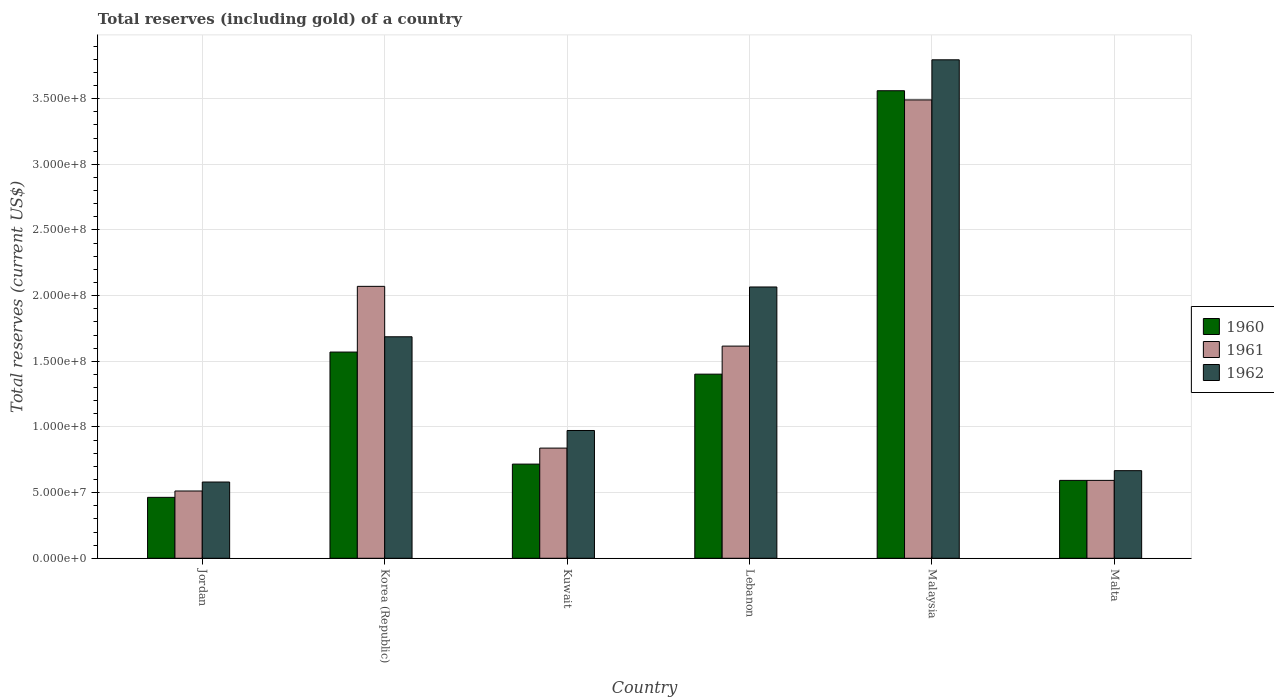How many different coloured bars are there?
Ensure brevity in your answer.  3. How many groups of bars are there?
Make the answer very short. 6. How many bars are there on the 2nd tick from the right?
Your response must be concise. 3. What is the label of the 3rd group of bars from the left?
Your response must be concise. Kuwait. In how many cases, is the number of bars for a given country not equal to the number of legend labels?
Provide a succinct answer. 0. What is the total reserves (including gold) in 1962 in Malaysia?
Keep it short and to the point. 3.80e+08. Across all countries, what is the maximum total reserves (including gold) in 1962?
Your response must be concise. 3.80e+08. Across all countries, what is the minimum total reserves (including gold) in 1961?
Offer a terse response. 5.12e+07. In which country was the total reserves (including gold) in 1961 maximum?
Ensure brevity in your answer.  Malaysia. In which country was the total reserves (including gold) in 1961 minimum?
Your answer should be very brief. Jordan. What is the total total reserves (including gold) in 1960 in the graph?
Offer a very short reply. 8.31e+08. What is the difference between the total reserves (including gold) in 1961 in Malaysia and that in Malta?
Your response must be concise. 2.90e+08. What is the difference between the total reserves (including gold) in 1961 in Lebanon and the total reserves (including gold) in 1962 in Korea (Republic)?
Make the answer very short. -7.10e+06. What is the average total reserves (including gold) in 1960 per country?
Give a very brief answer. 1.38e+08. What is the difference between the total reserves (including gold) of/in 1960 and total reserves (including gold) of/in 1961 in Kuwait?
Keep it short and to the point. -1.22e+07. In how many countries, is the total reserves (including gold) in 1962 greater than 180000000 US$?
Give a very brief answer. 2. What is the ratio of the total reserves (including gold) in 1960 in Jordan to that in Kuwait?
Your answer should be compact. 0.65. Is the difference between the total reserves (including gold) in 1960 in Malaysia and Malta greater than the difference between the total reserves (including gold) in 1961 in Malaysia and Malta?
Make the answer very short. Yes. What is the difference between the highest and the second highest total reserves (including gold) in 1961?
Offer a terse response. 1.87e+08. What is the difference between the highest and the lowest total reserves (including gold) in 1960?
Offer a terse response. 3.10e+08. What does the 2nd bar from the left in Lebanon represents?
Keep it short and to the point. 1961. How many bars are there?
Provide a succinct answer. 18. Are all the bars in the graph horizontal?
Offer a terse response. No. Are the values on the major ticks of Y-axis written in scientific E-notation?
Ensure brevity in your answer.  Yes. Does the graph contain any zero values?
Give a very brief answer. No. Does the graph contain grids?
Your response must be concise. Yes. How many legend labels are there?
Offer a terse response. 3. How are the legend labels stacked?
Your answer should be compact. Vertical. What is the title of the graph?
Make the answer very short. Total reserves (including gold) of a country. What is the label or title of the Y-axis?
Make the answer very short. Total reserves (current US$). What is the Total reserves (current US$) of 1960 in Jordan?
Offer a terse response. 4.64e+07. What is the Total reserves (current US$) of 1961 in Jordan?
Provide a short and direct response. 5.12e+07. What is the Total reserves (current US$) of 1962 in Jordan?
Your answer should be compact. 5.80e+07. What is the Total reserves (current US$) in 1960 in Korea (Republic)?
Give a very brief answer. 1.57e+08. What is the Total reserves (current US$) in 1961 in Korea (Republic)?
Offer a terse response. 2.07e+08. What is the Total reserves (current US$) of 1962 in Korea (Republic)?
Ensure brevity in your answer.  1.69e+08. What is the Total reserves (current US$) in 1960 in Kuwait?
Provide a succinct answer. 7.17e+07. What is the Total reserves (current US$) of 1961 in Kuwait?
Your response must be concise. 8.39e+07. What is the Total reserves (current US$) in 1962 in Kuwait?
Your answer should be compact. 9.73e+07. What is the Total reserves (current US$) in 1960 in Lebanon?
Your answer should be very brief. 1.40e+08. What is the Total reserves (current US$) in 1961 in Lebanon?
Make the answer very short. 1.62e+08. What is the Total reserves (current US$) in 1962 in Lebanon?
Provide a succinct answer. 2.07e+08. What is the Total reserves (current US$) of 1960 in Malaysia?
Give a very brief answer. 3.56e+08. What is the Total reserves (current US$) in 1961 in Malaysia?
Provide a succinct answer. 3.49e+08. What is the Total reserves (current US$) of 1962 in Malaysia?
Your answer should be very brief. 3.80e+08. What is the Total reserves (current US$) of 1960 in Malta?
Give a very brief answer. 5.93e+07. What is the Total reserves (current US$) in 1961 in Malta?
Provide a succinct answer. 5.93e+07. What is the Total reserves (current US$) in 1962 in Malta?
Ensure brevity in your answer.  6.67e+07. Across all countries, what is the maximum Total reserves (current US$) of 1960?
Give a very brief answer. 3.56e+08. Across all countries, what is the maximum Total reserves (current US$) of 1961?
Give a very brief answer. 3.49e+08. Across all countries, what is the maximum Total reserves (current US$) of 1962?
Your answer should be very brief. 3.80e+08. Across all countries, what is the minimum Total reserves (current US$) of 1960?
Ensure brevity in your answer.  4.64e+07. Across all countries, what is the minimum Total reserves (current US$) of 1961?
Keep it short and to the point. 5.12e+07. Across all countries, what is the minimum Total reserves (current US$) of 1962?
Give a very brief answer. 5.80e+07. What is the total Total reserves (current US$) in 1960 in the graph?
Give a very brief answer. 8.31e+08. What is the total Total reserves (current US$) in 1961 in the graph?
Ensure brevity in your answer.  9.12e+08. What is the total Total reserves (current US$) of 1962 in the graph?
Provide a short and direct response. 9.77e+08. What is the difference between the Total reserves (current US$) in 1960 in Jordan and that in Korea (Republic)?
Provide a succinct answer. -1.11e+08. What is the difference between the Total reserves (current US$) of 1961 in Jordan and that in Korea (Republic)?
Offer a very short reply. -1.56e+08. What is the difference between the Total reserves (current US$) in 1962 in Jordan and that in Korea (Republic)?
Your answer should be compact. -1.11e+08. What is the difference between the Total reserves (current US$) of 1960 in Jordan and that in Kuwait?
Make the answer very short. -2.53e+07. What is the difference between the Total reserves (current US$) of 1961 in Jordan and that in Kuwait?
Your answer should be compact. -3.27e+07. What is the difference between the Total reserves (current US$) of 1962 in Jordan and that in Kuwait?
Offer a very short reply. -3.92e+07. What is the difference between the Total reserves (current US$) of 1960 in Jordan and that in Lebanon?
Offer a very short reply. -9.38e+07. What is the difference between the Total reserves (current US$) of 1961 in Jordan and that in Lebanon?
Offer a terse response. -1.10e+08. What is the difference between the Total reserves (current US$) in 1962 in Jordan and that in Lebanon?
Your answer should be compact. -1.49e+08. What is the difference between the Total reserves (current US$) in 1960 in Jordan and that in Malaysia?
Give a very brief answer. -3.10e+08. What is the difference between the Total reserves (current US$) in 1961 in Jordan and that in Malaysia?
Your answer should be very brief. -2.98e+08. What is the difference between the Total reserves (current US$) in 1962 in Jordan and that in Malaysia?
Offer a very short reply. -3.21e+08. What is the difference between the Total reserves (current US$) of 1960 in Jordan and that in Malta?
Your response must be concise. -1.29e+07. What is the difference between the Total reserves (current US$) of 1961 in Jordan and that in Malta?
Provide a short and direct response. -8.07e+06. What is the difference between the Total reserves (current US$) of 1962 in Jordan and that in Malta?
Your answer should be compact. -8.65e+06. What is the difference between the Total reserves (current US$) in 1960 in Korea (Republic) and that in Kuwait?
Your answer should be very brief. 8.53e+07. What is the difference between the Total reserves (current US$) in 1961 in Korea (Republic) and that in Kuwait?
Ensure brevity in your answer.  1.23e+08. What is the difference between the Total reserves (current US$) in 1962 in Korea (Republic) and that in Kuwait?
Keep it short and to the point. 7.14e+07. What is the difference between the Total reserves (current US$) in 1960 in Korea (Republic) and that in Lebanon?
Offer a very short reply. 1.68e+07. What is the difference between the Total reserves (current US$) in 1961 in Korea (Republic) and that in Lebanon?
Give a very brief answer. 4.55e+07. What is the difference between the Total reserves (current US$) of 1962 in Korea (Republic) and that in Lebanon?
Make the answer very short. -3.79e+07. What is the difference between the Total reserves (current US$) in 1960 in Korea (Republic) and that in Malaysia?
Keep it short and to the point. -1.99e+08. What is the difference between the Total reserves (current US$) in 1961 in Korea (Republic) and that in Malaysia?
Give a very brief answer. -1.42e+08. What is the difference between the Total reserves (current US$) of 1962 in Korea (Republic) and that in Malaysia?
Offer a very short reply. -2.11e+08. What is the difference between the Total reserves (current US$) of 1960 in Korea (Republic) and that in Malta?
Your answer should be very brief. 9.77e+07. What is the difference between the Total reserves (current US$) of 1961 in Korea (Republic) and that in Malta?
Offer a very short reply. 1.48e+08. What is the difference between the Total reserves (current US$) in 1962 in Korea (Republic) and that in Malta?
Your response must be concise. 1.02e+08. What is the difference between the Total reserves (current US$) in 1960 in Kuwait and that in Lebanon?
Provide a succinct answer. -6.85e+07. What is the difference between the Total reserves (current US$) of 1961 in Kuwait and that in Lebanon?
Your response must be concise. -7.77e+07. What is the difference between the Total reserves (current US$) in 1962 in Kuwait and that in Lebanon?
Make the answer very short. -1.09e+08. What is the difference between the Total reserves (current US$) of 1960 in Kuwait and that in Malaysia?
Ensure brevity in your answer.  -2.84e+08. What is the difference between the Total reserves (current US$) of 1961 in Kuwait and that in Malaysia?
Offer a terse response. -2.65e+08. What is the difference between the Total reserves (current US$) in 1962 in Kuwait and that in Malaysia?
Provide a succinct answer. -2.82e+08. What is the difference between the Total reserves (current US$) of 1960 in Kuwait and that in Malta?
Offer a terse response. 1.24e+07. What is the difference between the Total reserves (current US$) of 1961 in Kuwait and that in Malta?
Provide a short and direct response. 2.46e+07. What is the difference between the Total reserves (current US$) of 1962 in Kuwait and that in Malta?
Offer a terse response. 3.06e+07. What is the difference between the Total reserves (current US$) in 1960 in Lebanon and that in Malaysia?
Ensure brevity in your answer.  -2.16e+08. What is the difference between the Total reserves (current US$) in 1961 in Lebanon and that in Malaysia?
Ensure brevity in your answer.  -1.87e+08. What is the difference between the Total reserves (current US$) of 1962 in Lebanon and that in Malaysia?
Give a very brief answer. -1.73e+08. What is the difference between the Total reserves (current US$) of 1960 in Lebanon and that in Malta?
Your answer should be very brief. 8.09e+07. What is the difference between the Total reserves (current US$) in 1961 in Lebanon and that in Malta?
Provide a succinct answer. 1.02e+08. What is the difference between the Total reserves (current US$) in 1962 in Lebanon and that in Malta?
Your response must be concise. 1.40e+08. What is the difference between the Total reserves (current US$) of 1960 in Malaysia and that in Malta?
Provide a succinct answer. 2.97e+08. What is the difference between the Total reserves (current US$) in 1961 in Malaysia and that in Malta?
Your answer should be compact. 2.90e+08. What is the difference between the Total reserves (current US$) of 1962 in Malaysia and that in Malta?
Make the answer very short. 3.13e+08. What is the difference between the Total reserves (current US$) of 1960 in Jordan and the Total reserves (current US$) of 1961 in Korea (Republic)?
Your answer should be compact. -1.61e+08. What is the difference between the Total reserves (current US$) in 1960 in Jordan and the Total reserves (current US$) in 1962 in Korea (Republic)?
Provide a short and direct response. -1.22e+08. What is the difference between the Total reserves (current US$) of 1961 in Jordan and the Total reserves (current US$) of 1962 in Korea (Republic)?
Your answer should be very brief. -1.17e+08. What is the difference between the Total reserves (current US$) of 1960 in Jordan and the Total reserves (current US$) of 1961 in Kuwait?
Give a very brief answer. -3.75e+07. What is the difference between the Total reserves (current US$) in 1960 in Jordan and the Total reserves (current US$) in 1962 in Kuwait?
Your answer should be compact. -5.09e+07. What is the difference between the Total reserves (current US$) of 1961 in Jordan and the Total reserves (current US$) of 1962 in Kuwait?
Make the answer very short. -4.61e+07. What is the difference between the Total reserves (current US$) of 1960 in Jordan and the Total reserves (current US$) of 1961 in Lebanon?
Offer a very short reply. -1.15e+08. What is the difference between the Total reserves (current US$) in 1960 in Jordan and the Total reserves (current US$) in 1962 in Lebanon?
Provide a short and direct response. -1.60e+08. What is the difference between the Total reserves (current US$) of 1961 in Jordan and the Total reserves (current US$) of 1962 in Lebanon?
Provide a short and direct response. -1.55e+08. What is the difference between the Total reserves (current US$) of 1960 in Jordan and the Total reserves (current US$) of 1961 in Malaysia?
Provide a short and direct response. -3.03e+08. What is the difference between the Total reserves (current US$) of 1960 in Jordan and the Total reserves (current US$) of 1962 in Malaysia?
Offer a very short reply. -3.33e+08. What is the difference between the Total reserves (current US$) in 1961 in Jordan and the Total reserves (current US$) in 1962 in Malaysia?
Keep it short and to the point. -3.28e+08. What is the difference between the Total reserves (current US$) in 1960 in Jordan and the Total reserves (current US$) in 1961 in Malta?
Provide a succinct answer. -1.29e+07. What is the difference between the Total reserves (current US$) of 1960 in Jordan and the Total reserves (current US$) of 1962 in Malta?
Your answer should be compact. -2.03e+07. What is the difference between the Total reserves (current US$) of 1961 in Jordan and the Total reserves (current US$) of 1962 in Malta?
Your answer should be very brief. -1.55e+07. What is the difference between the Total reserves (current US$) in 1960 in Korea (Republic) and the Total reserves (current US$) in 1961 in Kuwait?
Ensure brevity in your answer.  7.31e+07. What is the difference between the Total reserves (current US$) of 1960 in Korea (Republic) and the Total reserves (current US$) of 1962 in Kuwait?
Provide a succinct answer. 5.97e+07. What is the difference between the Total reserves (current US$) in 1961 in Korea (Republic) and the Total reserves (current US$) in 1962 in Kuwait?
Keep it short and to the point. 1.10e+08. What is the difference between the Total reserves (current US$) of 1960 in Korea (Republic) and the Total reserves (current US$) of 1961 in Lebanon?
Your response must be concise. -4.54e+06. What is the difference between the Total reserves (current US$) in 1960 in Korea (Republic) and the Total reserves (current US$) in 1962 in Lebanon?
Offer a terse response. -4.95e+07. What is the difference between the Total reserves (current US$) of 1961 in Korea (Republic) and the Total reserves (current US$) of 1962 in Lebanon?
Give a very brief answer. 4.83e+05. What is the difference between the Total reserves (current US$) of 1960 in Korea (Republic) and the Total reserves (current US$) of 1961 in Malaysia?
Offer a very short reply. -1.92e+08. What is the difference between the Total reserves (current US$) in 1960 in Korea (Republic) and the Total reserves (current US$) in 1962 in Malaysia?
Provide a succinct answer. -2.23e+08. What is the difference between the Total reserves (current US$) in 1961 in Korea (Republic) and the Total reserves (current US$) in 1962 in Malaysia?
Ensure brevity in your answer.  -1.72e+08. What is the difference between the Total reserves (current US$) in 1960 in Korea (Republic) and the Total reserves (current US$) in 1961 in Malta?
Ensure brevity in your answer.  9.77e+07. What is the difference between the Total reserves (current US$) of 1960 in Korea (Republic) and the Total reserves (current US$) of 1962 in Malta?
Your answer should be very brief. 9.03e+07. What is the difference between the Total reserves (current US$) in 1961 in Korea (Republic) and the Total reserves (current US$) in 1962 in Malta?
Offer a terse response. 1.40e+08. What is the difference between the Total reserves (current US$) in 1960 in Kuwait and the Total reserves (current US$) in 1961 in Lebanon?
Your answer should be very brief. -8.99e+07. What is the difference between the Total reserves (current US$) of 1960 in Kuwait and the Total reserves (current US$) of 1962 in Lebanon?
Offer a very short reply. -1.35e+08. What is the difference between the Total reserves (current US$) in 1961 in Kuwait and the Total reserves (current US$) in 1962 in Lebanon?
Provide a short and direct response. -1.23e+08. What is the difference between the Total reserves (current US$) in 1960 in Kuwait and the Total reserves (current US$) in 1961 in Malaysia?
Make the answer very short. -2.77e+08. What is the difference between the Total reserves (current US$) of 1960 in Kuwait and the Total reserves (current US$) of 1962 in Malaysia?
Make the answer very short. -3.08e+08. What is the difference between the Total reserves (current US$) in 1961 in Kuwait and the Total reserves (current US$) in 1962 in Malaysia?
Keep it short and to the point. -2.96e+08. What is the difference between the Total reserves (current US$) in 1960 in Kuwait and the Total reserves (current US$) in 1961 in Malta?
Your response must be concise. 1.24e+07. What is the difference between the Total reserves (current US$) of 1961 in Kuwait and the Total reserves (current US$) of 1962 in Malta?
Ensure brevity in your answer.  1.72e+07. What is the difference between the Total reserves (current US$) of 1960 in Lebanon and the Total reserves (current US$) of 1961 in Malaysia?
Your answer should be compact. -2.09e+08. What is the difference between the Total reserves (current US$) of 1960 in Lebanon and the Total reserves (current US$) of 1962 in Malaysia?
Provide a short and direct response. -2.39e+08. What is the difference between the Total reserves (current US$) in 1961 in Lebanon and the Total reserves (current US$) in 1962 in Malaysia?
Give a very brief answer. -2.18e+08. What is the difference between the Total reserves (current US$) in 1960 in Lebanon and the Total reserves (current US$) in 1961 in Malta?
Offer a terse response. 8.09e+07. What is the difference between the Total reserves (current US$) of 1960 in Lebanon and the Total reserves (current US$) of 1962 in Malta?
Provide a succinct answer. 7.35e+07. What is the difference between the Total reserves (current US$) in 1961 in Lebanon and the Total reserves (current US$) in 1962 in Malta?
Offer a very short reply. 9.49e+07. What is the difference between the Total reserves (current US$) in 1960 in Malaysia and the Total reserves (current US$) in 1961 in Malta?
Your response must be concise. 2.97e+08. What is the difference between the Total reserves (current US$) of 1960 in Malaysia and the Total reserves (current US$) of 1962 in Malta?
Keep it short and to the point. 2.89e+08. What is the difference between the Total reserves (current US$) of 1961 in Malaysia and the Total reserves (current US$) of 1962 in Malta?
Provide a succinct answer. 2.82e+08. What is the average Total reserves (current US$) of 1960 per country?
Provide a short and direct response. 1.38e+08. What is the average Total reserves (current US$) of 1961 per country?
Make the answer very short. 1.52e+08. What is the average Total reserves (current US$) of 1962 per country?
Make the answer very short. 1.63e+08. What is the difference between the Total reserves (current US$) in 1960 and Total reserves (current US$) in 1961 in Jordan?
Your answer should be very brief. -4.85e+06. What is the difference between the Total reserves (current US$) of 1960 and Total reserves (current US$) of 1962 in Jordan?
Keep it short and to the point. -1.17e+07. What is the difference between the Total reserves (current US$) in 1961 and Total reserves (current US$) in 1962 in Jordan?
Provide a succinct answer. -6.82e+06. What is the difference between the Total reserves (current US$) in 1960 and Total reserves (current US$) in 1961 in Korea (Republic)?
Make the answer very short. -5.00e+07. What is the difference between the Total reserves (current US$) in 1960 and Total reserves (current US$) in 1962 in Korea (Republic)?
Offer a very short reply. -1.16e+07. What is the difference between the Total reserves (current US$) in 1961 and Total reserves (current US$) in 1962 in Korea (Republic)?
Give a very brief answer. 3.84e+07. What is the difference between the Total reserves (current US$) in 1960 and Total reserves (current US$) in 1961 in Kuwait?
Make the answer very short. -1.22e+07. What is the difference between the Total reserves (current US$) of 1960 and Total reserves (current US$) of 1962 in Kuwait?
Offer a terse response. -2.56e+07. What is the difference between the Total reserves (current US$) of 1961 and Total reserves (current US$) of 1962 in Kuwait?
Keep it short and to the point. -1.34e+07. What is the difference between the Total reserves (current US$) in 1960 and Total reserves (current US$) in 1961 in Lebanon?
Provide a succinct answer. -2.14e+07. What is the difference between the Total reserves (current US$) of 1960 and Total reserves (current US$) of 1962 in Lebanon?
Make the answer very short. -6.64e+07. What is the difference between the Total reserves (current US$) of 1961 and Total reserves (current US$) of 1962 in Lebanon?
Make the answer very short. -4.50e+07. What is the difference between the Total reserves (current US$) of 1960 and Total reserves (current US$) of 1961 in Malaysia?
Give a very brief answer. 7.00e+06. What is the difference between the Total reserves (current US$) of 1960 and Total reserves (current US$) of 1962 in Malaysia?
Make the answer very short. -2.35e+07. What is the difference between the Total reserves (current US$) of 1961 and Total reserves (current US$) of 1962 in Malaysia?
Offer a terse response. -3.05e+07. What is the difference between the Total reserves (current US$) in 1960 and Total reserves (current US$) in 1962 in Malta?
Your answer should be very brief. -7.40e+06. What is the difference between the Total reserves (current US$) in 1961 and Total reserves (current US$) in 1962 in Malta?
Offer a terse response. -7.40e+06. What is the ratio of the Total reserves (current US$) in 1960 in Jordan to that in Korea (Republic)?
Provide a short and direct response. 0.3. What is the ratio of the Total reserves (current US$) of 1961 in Jordan to that in Korea (Republic)?
Keep it short and to the point. 0.25. What is the ratio of the Total reserves (current US$) in 1962 in Jordan to that in Korea (Republic)?
Offer a terse response. 0.34. What is the ratio of the Total reserves (current US$) in 1960 in Jordan to that in Kuwait?
Keep it short and to the point. 0.65. What is the ratio of the Total reserves (current US$) in 1961 in Jordan to that in Kuwait?
Provide a short and direct response. 0.61. What is the ratio of the Total reserves (current US$) of 1962 in Jordan to that in Kuwait?
Provide a short and direct response. 0.6. What is the ratio of the Total reserves (current US$) in 1960 in Jordan to that in Lebanon?
Offer a very short reply. 0.33. What is the ratio of the Total reserves (current US$) of 1961 in Jordan to that in Lebanon?
Your answer should be very brief. 0.32. What is the ratio of the Total reserves (current US$) in 1962 in Jordan to that in Lebanon?
Keep it short and to the point. 0.28. What is the ratio of the Total reserves (current US$) of 1960 in Jordan to that in Malaysia?
Your answer should be very brief. 0.13. What is the ratio of the Total reserves (current US$) in 1961 in Jordan to that in Malaysia?
Provide a succinct answer. 0.15. What is the ratio of the Total reserves (current US$) in 1962 in Jordan to that in Malaysia?
Provide a succinct answer. 0.15. What is the ratio of the Total reserves (current US$) in 1960 in Jordan to that in Malta?
Keep it short and to the point. 0.78. What is the ratio of the Total reserves (current US$) of 1961 in Jordan to that in Malta?
Offer a terse response. 0.86. What is the ratio of the Total reserves (current US$) of 1962 in Jordan to that in Malta?
Provide a short and direct response. 0.87. What is the ratio of the Total reserves (current US$) in 1960 in Korea (Republic) to that in Kuwait?
Ensure brevity in your answer.  2.19. What is the ratio of the Total reserves (current US$) of 1961 in Korea (Republic) to that in Kuwait?
Your answer should be very brief. 2.47. What is the ratio of the Total reserves (current US$) in 1962 in Korea (Republic) to that in Kuwait?
Provide a short and direct response. 1.73. What is the ratio of the Total reserves (current US$) of 1960 in Korea (Republic) to that in Lebanon?
Your response must be concise. 1.12. What is the ratio of the Total reserves (current US$) in 1961 in Korea (Republic) to that in Lebanon?
Offer a terse response. 1.28. What is the ratio of the Total reserves (current US$) of 1962 in Korea (Republic) to that in Lebanon?
Provide a short and direct response. 0.82. What is the ratio of the Total reserves (current US$) in 1960 in Korea (Republic) to that in Malaysia?
Keep it short and to the point. 0.44. What is the ratio of the Total reserves (current US$) in 1961 in Korea (Republic) to that in Malaysia?
Provide a succinct answer. 0.59. What is the ratio of the Total reserves (current US$) in 1962 in Korea (Republic) to that in Malaysia?
Offer a terse response. 0.44. What is the ratio of the Total reserves (current US$) in 1960 in Korea (Republic) to that in Malta?
Provide a short and direct response. 2.65. What is the ratio of the Total reserves (current US$) in 1961 in Korea (Republic) to that in Malta?
Keep it short and to the point. 3.49. What is the ratio of the Total reserves (current US$) of 1962 in Korea (Republic) to that in Malta?
Offer a terse response. 2.53. What is the ratio of the Total reserves (current US$) in 1960 in Kuwait to that in Lebanon?
Ensure brevity in your answer.  0.51. What is the ratio of the Total reserves (current US$) in 1961 in Kuwait to that in Lebanon?
Give a very brief answer. 0.52. What is the ratio of the Total reserves (current US$) of 1962 in Kuwait to that in Lebanon?
Your response must be concise. 0.47. What is the ratio of the Total reserves (current US$) in 1960 in Kuwait to that in Malaysia?
Your response must be concise. 0.2. What is the ratio of the Total reserves (current US$) in 1961 in Kuwait to that in Malaysia?
Your answer should be compact. 0.24. What is the ratio of the Total reserves (current US$) of 1962 in Kuwait to that in Malaysia?
Your response must be concise. 0.26. What is the ratio of the Total reserves (current US$) of 1960 in Kuwait to that in Malta?
Provide a succinct answer. 1.21. What is the ratio of the Total reserves (current US$) of 1961 in Kuwait to that in Malta?
Offer a very short reply. 1.41. What is the ratio of the Total reserves (current US$) in 1962 in Kuwait to that in Malta?
Give a very brief answer. 1.46. What is the ratio of the Total reserves (current US$) of 1960 in Lebanon to that in Malaysia?
Offer a terse response. 0.39. What is the ratio of the Total reserves (current US$) in 1961 in Lebanon to that in Malaysia?
Offer a terse response. 0.46. What is the ratio of the Total reserves (current US$) in 1962 in Lebanon to that in Malaysia?
Provide a short and direct response. 0.54. What is the ratio of the Total reserves (current US$) in 1960 in Lebanon to that in Malta?
Your answer should be very brief. 2.36. What is the ratio of the Total reserves (current US$) in 1961 in Lebanon to that in Malta?
Keep it short and to the point. 2.72. What is the ratio of the Total reserves (current US$) in 1962 in Lebanon to that in Malta?
Your answer should be very brief. 3.1. What is the ratio of the Total reserves (current US$) of 1960 in Malaysia to that in Malta?
Provide a succinct answer. 6. What is the ratio of the Total reserves (current US$) of 1961 in Malaysia to that in Malta?
Offer a very short reply. 5.89. What is the ratio of the Total reserves (current US$) in 1962 in Malaysia to that in Malta?
Give a very brief answer. 5.69. What is the difference between the highest and the second highest Total reserves (current US$) of 1960?
Provide a succinct answer. 1.99e+08. What is the difference between the highest and the second highest Total reserves (current US$) in 1961?
Make the answer very short. 1.42e+08. What is the difference between the highest and the second highest Total reserves (current US$) of 1962?
Offer a terse response. 1.73e+08. What is the difference between the highest and the lowest Total reserves (current US$) in 1960?
Provide a succinct answer. 3.10e+08. What is the difference between the highest and the lowest Total reserves (current US$) of 1961?
Provide a succinct answer. 2.98e+08. What is the difference between the highest and the lowest Total reserves (current US$) of 1962?
Offer a very short reply. 3.21e+08. 